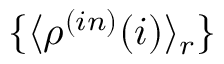Convert formula to latex. <formula><loc_0><loc_0><loc_500><loc_500>\{ \langle \rho ^ { ( i n ) } ( i ) \rangle _ { r } \}</formula> 